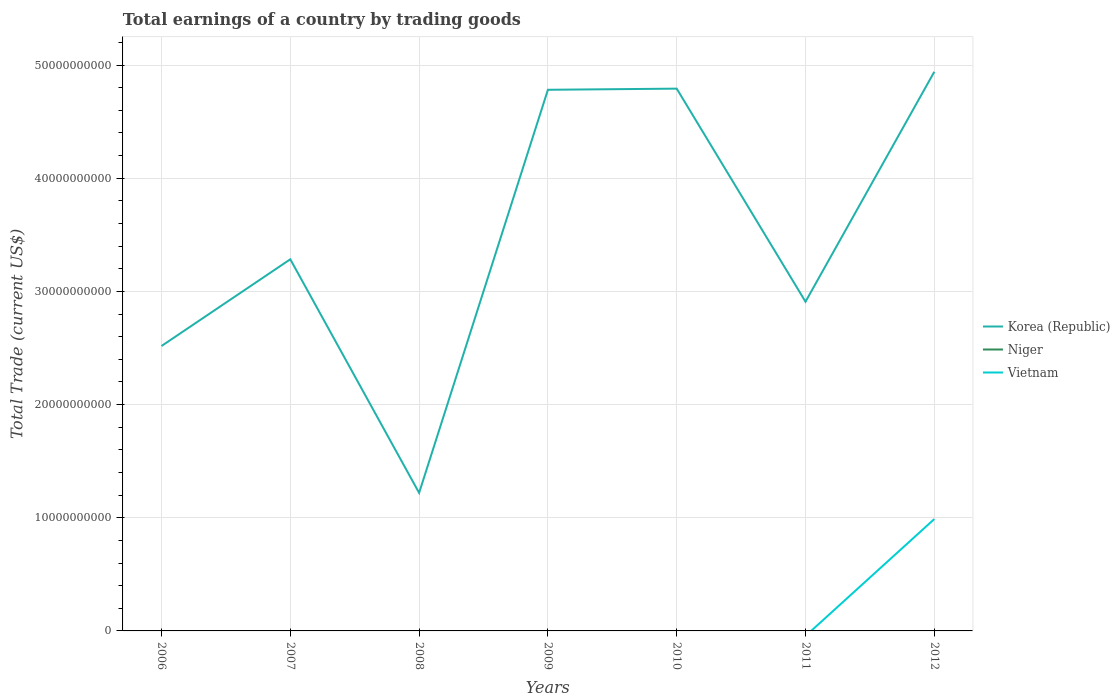Does the line corresponding to Vietnam intersect with the line corresponding to Niger?
Ensure brevity in your answer.  Yes. Is the number of lines equal to the number of legend labels?
Your answer should be very brief. No. What is the total total earnings in Korea (Republic) in the graph?
Provide a succinct answer. 1.87e+1. What is the difference between the highest and the second highest total earnings in Korea (Republic)?
Offer a very short reply. 3.72e+1. What is the difference between the highest and the lowest total earnings in Vietnam?
Offer a very short reply. 1. Is the total earnings in Niger strictly greater than the total earnings in Vietnam over the years?
Your response must be concise. No. How many lines are there?
Offer a terse response. 2. How many years are there in the graph?
Ensure brevity in your answer.  7. What is the difference between two consecutive major ticks on the Y-axis?
Provide a short and direct response. 1.00e+1. Where does the legend appear in the graph?
Ensure brevity in your answer.  Center right. What is the title of the graph?
Offer a terse response. Total earnings of a country by trading goods. What is the label or title of the X-axis?
Your response must be concise. Years. What is the label or title of the Y-axis?
Give a very brief answer. Total Trade (current US$). What is the Total Trade (current US$) in Korea (Republic) in 2006?
Ensure brevity in your answer.  2.52e+1. What is the Total Trade (current US$) in Korea (Republic) in 2007?
Provide a succinct answer. 3.28e+1. What is the Total Trade (current US$) in Niger in 2007?
Offer a terse response. 0. What is the Total Trade (current US$) in Vietnam in 2007?
Provide a succinct answer. 0. What is the Total Trade (current US$) of Korea (Republic) in 2008?
Your answer should be compact. 1.22e+1. What is the Total Trade (current US$) of Vietnam in 2008?
Offer a very short reply. 0. What is the Total Trade (current US$) in Korea (Republic) in 2009?
Offer a very short reply. 4.78e+1. What is the Total Trade (current US$) of Niger in 2009?
Give a very brief answer. 0. What is the Total Trade (current US$) of Korea (Republic) in 2010?
Your answer should be compact. 4.79e+1. What is the Total Trade (current US$) of Niger in 2010?
Offer a terse response. 0. What is the Total Trade (current US$) of Korea (Republic) in 2011?
Keep it short and to the point. 2.91e+1. What is the Total Trade (current US$) of Vietnam in 2011?
Keep it short and to the point. 0. What is the Total Trade (current US$) of Korea (Republic) in 2012?
Your response must be concise. 4.94e+1. What is the Total Trade (current US$) of Niger in 2012?
Provide a succinct answer. 0. What is the Total Trade (current US$) of Vietnam in 2012?
Make the answer very short. 9.88e+09. Across all years, what is the maximum Total Trade (current US$) in Korea (Republic)?
Provide a short and direct response. 4.94e+1. Across all years, what is the maximum Total Trade (current US$) in Vietnam?
Keep it short and to the point. 9.88e+09. Across all years, what is the minimum Total Trade (current US$) in Korea (Republic)?
Ensure brevity in your answer.  1.22e+1. Across all years, what is the minimum Total Trade (current US$) of Vietnam?
Your answer should be very brief. 0. What is the total Total Trade (current US$) of Korea (Republic) in the graph?
Offer a terse response. 2.44e+11. What is the total Total Trade (current US$) of Niger in the graph?
Ensure brevity in your answer.  0. What is the total Total Trade (current US$) in Vietnam in the graph?
Offer a terse response. 9.88e+09. What is the difference between the Total Trade (current US$) in Korea (Republic) in 2006 and that in 2007?
Your response must be concise. -7.66e+09. What is the difference between the Total Trade (current US$) of Korea (Republic) in 2006 and that in 2008?
Ensure brevity in your answer.  1.30e+1. What is the difference between the Total Trade (current US$) in Korea (Republic) in 2006 and that in 2009?
Ensure brevity in your answer.  -2.26e+1. What is the difference between the Total Trade (current US$) of Korea (Republic) in 2006 and that in 2010?
Give a very brief answer. -2.27e+1. What is the difference between the Total Trade (current US$) in Korea (Republic) in 2006 and that in 2011?
Your answer should be compact. -3.92e+09. What is the difference between the Total Trade (current US$) in Korea (Republic) in 2006 and that in 2012?
Your answer should be compact. -2.42e+1. What is the difference between the Total Trade (current US$) of Korea (Republic) in 2007 and that in 2008?
Your answer should be very brief. 2.06e+1. What is the difference between the Total Trade (current US$) in Korea (Republic) in 2007 and that in 2009?
Ensure brevity in your answer.  -1.50e+1. What is the difference between the Total Trade (current US$) in Korea (Republic) in 2007 and that in 2010?
Offer a terse response. -1.51e+1. What is the difference between the Total Trade (current US$) in Korea (Republic) in 2007 and that in 2011?
Provide a succinct answer. 3.75e+09. What is the difference between the Total Trade (current US$) of Korea (Republic) in 2007 and that in 2012?
Give a very brief answer. -1.66e+1. What is the difference between the Total Trade (current US$) in Korea (Republic) in 2008 and that in 2009?
Your response must be concise. -3.56e+1. What is the difference between the Total Trade (current US$) in Korea (Republic) in 2008 and that in 2010?
Your answer should be compact. -3.57e+1. What is the difference between the Total Trade (current US$) of Korea (Republic) in 2008 and that in 2011?
Offer a terse response. -1.69e+1. What is the difference between the Total Trade (current US$) of Korea (Republic) in 2008 and that in 2012?
Give a very brief answer. -3.72e+1. What is the difference between the Total Trade (current US$) of Korea (Republic) in 2009 and that in 2010?
Keep it short and to the point. -1.01e+08. What is the difference between the Total Trade (current US$) in Korea (Republic) in 2009 and that in 2011?
Give a very brief answer. 1.87e+1. What is the difference between the Total Trade (current US$) in Korea (Republic) in 2009 and that in 2012?
Ensure brevity in your answer.  -1.59e+09. What is the difference between the Total Trade (current US$) in Korea (Republic) in 2010 and that in 2011?
Your answer should be very brief. 1.88e+1. What is the difference between the Total Trade (current US$) in Korea (Republic) in 2010 and that in 2012?
Provide a short and direct response. -1.49e+09. What is the difference between the Total Trade (current US$) of Korea (Republic) in 2011 and that in 2012?
Make the answer very short. -2.03e+1. What is the difference between the Total Trade (current US$) in Korea (Republic) in 2006 and the Total Trade (current US$) in Vietnam in 2012?
Ensure brevity in your answer.  1.53e+1. What is the difference between the Total Trade (current US$) in Korea (Republic) in 2007 and the Total Trade (current US$) in Vietnam in 2012?
Provide a short and direct response. 2.30e+1. What is the difference between the Total Trade (current US$) in Korea (Republic) in 2008 and the Total Trade (current US$) in Vietnam in 2012?
Offer a very short reply. 2.31e+09. What is the difference between the Total Trade (current US$) of Korea (Republic) in 2009 and the Total Trade (current US$) of Vietnam in 2012?
Your response must be concise. 3.79e+1. What is the difference between the Total Trade (current US$) of Korea (Republic) in 2010 and the Total Trade (current US$) of Vietnam in 2012?
Provide a succinct answer. 3.80e+1. What is the difference between the Total Trade (current US$) in Korea (Republic) in 2011 and the Total Trade (current US$) in Vietnam in 2012?
Make the answer very short. 1.92e+1. What is the average Total Trade (current US$) of Korea (Republic) per year?
Ensure brevity in your answer.  3.49e+1. What is the average Total Trade (current US$) in Niger per year?
Your response must be concise. 0. What is the average Total Trade (current US$) of Vietnam per year?
Offer a very short reply. 1.41e+09. In the year 2012, what is the difference between the Total Trade (current US$) of Korea (Republic) and Total Trade (current US$) of Vietnam?
Provide a succinct answer. 3.95e+1. What is the ratio of the Total Trade (current US$) of Korea (Republic) in 2006 to that in 2007?
Ensure brevity in your answer.  0.77. What is the ratio of the Total Trade (current US$) of Korea (Republic) in 2006 to that in 2008?
Your answer should be very brief. 2.06. What is the ratio of the Total Trade (current US$) of Korea (Republic) in 2006 to that in 2009?
Provide a succinct answer. 0.53. What is the ratio of the Total Trade (current US$) of Korea (Republic) in 2006 to that in 2010?
Your response must be concise. 0.53. What is the ratio of the Total Trade (current US$) of Korea (Republic) in 2006 to that in 2011?
Make the answer very short. 0.87. What is the ratio of the Total Trade (current US$) of Korea (Republic) in 2006 to that in 2012?
Offer a terse response. 0.51. What is the ratio of the Total Trade (current US$) of Korea (Republic) in 2007 to that in 2008?
Make the answer very short. 2.69. What is the ratio of the Total Trade (current US$) of Korea (Republic) in 2007 to that in 2009?
Ensure brevity in your answer.  0.69. What is the ratio of the Total Trade (current US$) of Korea (Republic) in 2007 to that in 2010?
Give a very brief answer. 0.69. What is the ratio of the Total Trade (current US$) of Korea (Republic) in 2007 to that in 2011?
Your response must be concise. 1.13. What is the ratio of the Total Trade (current US$) in Korea (Republic) in 2007 to that in 2012?
Keep it short and to the point. 0.66. What is the ratio of the Total Trade (current US$) in Korea (Republic) in 2008 to that in 2009?
Offer a very short reply. 0.26. What is the ratio of the Total Trade (current US$) in Korea (Republic) in 2008 to that in 2010?
Your answer should be very brief. 0.25. What is the ratio of the Total Trade (current US$) of Korea (Republic) in 2008 to that in 2011?
Provide a short and direct response. 0.42. What is the ratio of the Total Trade (current US$) of Korea (Republic) in 2008 to that in 2012?
Your answer should be compact. 0.25. What is the ratio of the Total Trade (current US$) in Korea (Republic) in 2009 to that in 2010?
Your answer should be compact. 1. What is the ratio of the Total Trade (current US$) in Korea (Republic) in 2009 to that in 2011?
Your response must be concise. 1.64. What is the ratio of the Total Trade (current US$) in Korea (Republic) in 2009 to that in 2012?
Your answer should be very brief. 0.97. What is the ratio of the Total Trade (current US$) in Korea (Republic) in 2010 to that in 2011?
Keep it short and to the point. 1.65. What is the ratio of the Total Trade (current US$) in Korea (Republic) in 2010 to that in 2012?
Your answer should be compact. 0.97. What is the ratio of the Total Trade (current US$) in Korea (Republic) in 2011 to that in 2012?
Provide a succinct answer. 0.59. What is the difference between the highest and the second highest Total Trade (current US$) in Korea (Republic)?
Ensure brevity in your answer.  1.49e+09. What is the difference between the highest and the lowest Total Trade (current US$) of Korea (Republic)?
Offer a very short reply. 3.72e+1. What is the difference between the highest and the lowest Total Trade (current US$) in Vietnam?
Offer a very short reply. 9.88e+09. 